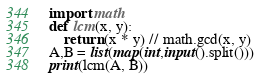<code> <loc_0><loc_0><loc_500><loc_500><_Python_>import math
def lcm(x, y):
    return (x * y) // math.gcd(x, y)
A,B = list(map(int,input().split()))
print(lcm(A, B))</code> 